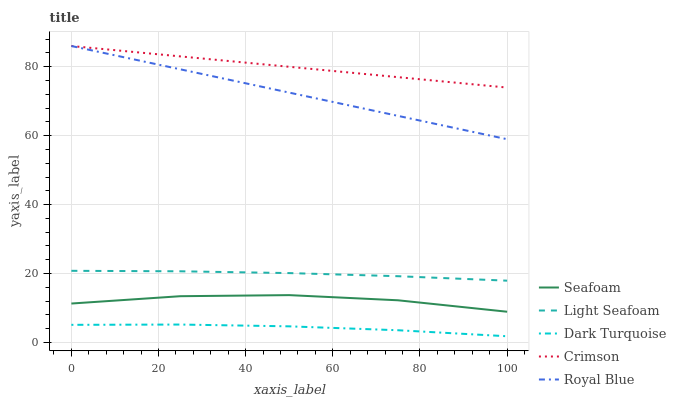Does Dark Turquoise have the minimum area under the curve?
Answer yes or no. Yes. Does Crimson have the maximum area under the curve?
Answer yes or no. Yes. Does Light Seafoam have the minimum area under the curve?
Answer yes or no. No. Does Light Seafoam have the maximum area under the curve?
Answer yes or no. No. Is Crimson the smoothest?
Answer yes or no. Yes. Is Seafoam the roughest?
Answer yes or no. Yes. Is Dark Turquoise the smoothest?
Answer yes or no. No. Is Dark Turquoise the roughest?
Answer yes or no. No. Does Dark Turquoise have the lowest value?
Answer yes or no. Yes. Does Light Seafoam have the lowest value?
Answer yes or no. No. Does Royal Blue have the highest value?
Answer yes or no. Yes. Does Light Seafoam have the highest value?
Answer yes or no. No. Is Seafoam less than Royal Blue?
Answer yes or no. Yes. Is Light Seafoam greater than Dark Turquoise?
Answer yes or no. Yes. Does Royal Blue intersect Crimson?
Answer yes or no. Yes. Is Royal Blue less than Crimson?
Answer yes or no. No. Is Royal Blue greater than Crimson?
Answer yes or no. No. Does Seafoam intersect Royal Blue?
Answer yes or no. No. 